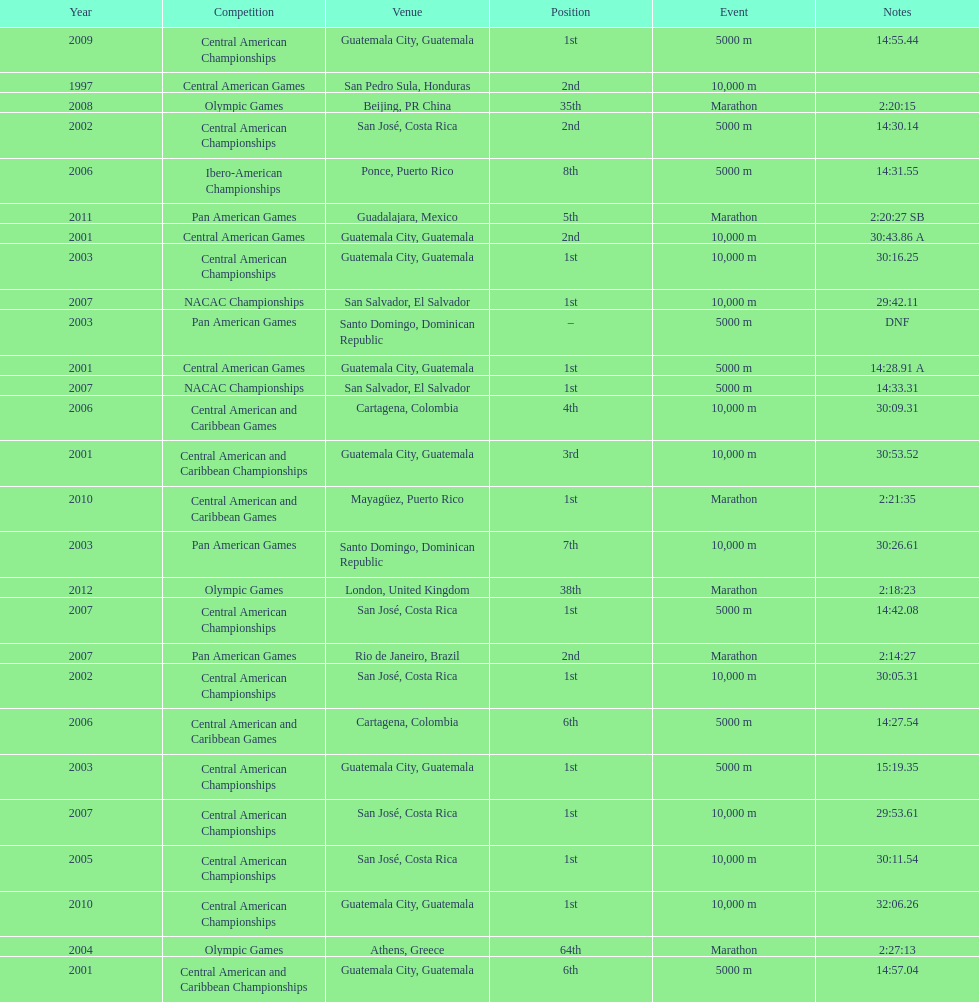What was the last competition in which a position of "2nd" was achieved? Pan American Games. 